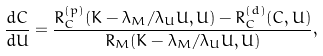<formula> <loc_0><loc_0><loc_500><loc_500>\frac { d C } { d U } = \frac { R _ { C } ^ { ( p ) } ( K - \lambda _ { M } / \lambda _ { U } U , U ) - R _ { C } ^ { ( d ) } ( C , U ) } { R _ { M } ( K - \lambda _ { M } / \lambda _ { U } U , U ) } ,</formula> 